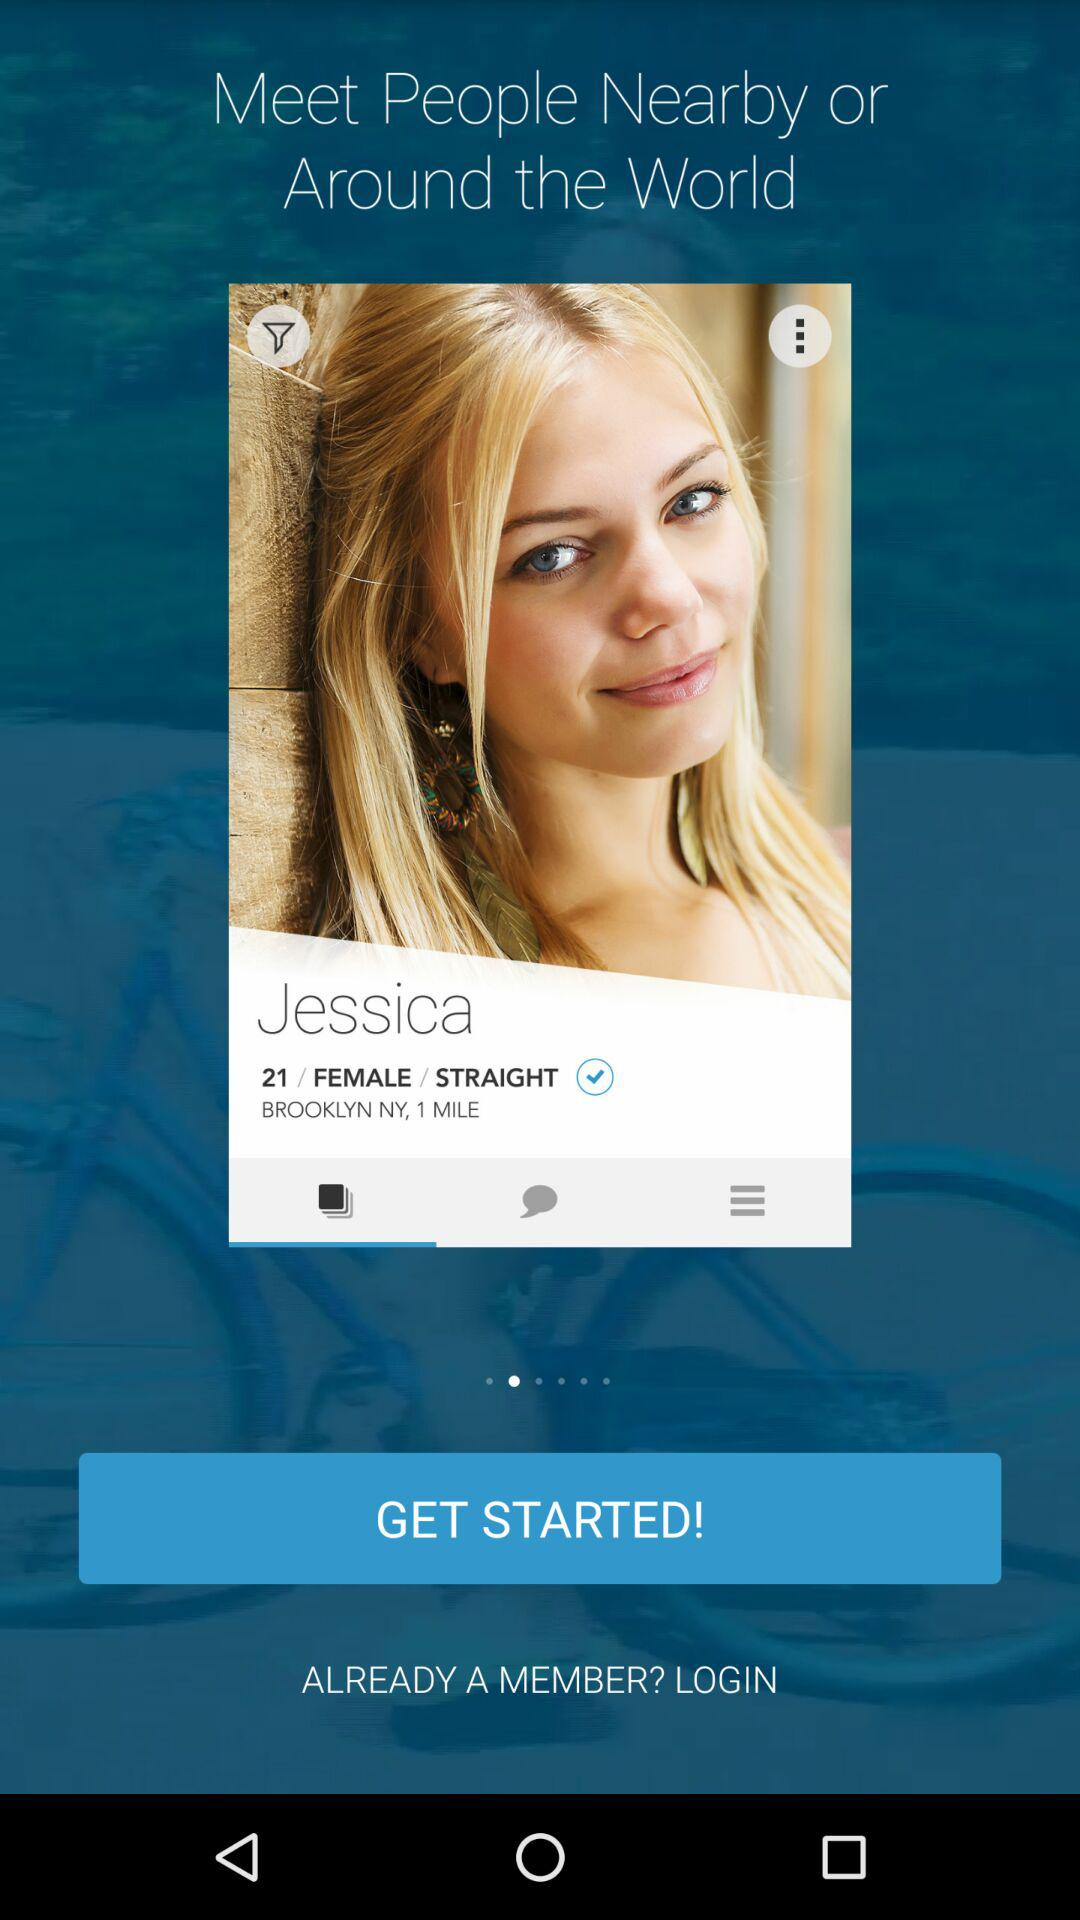What is the given gender? The given gender is female. 